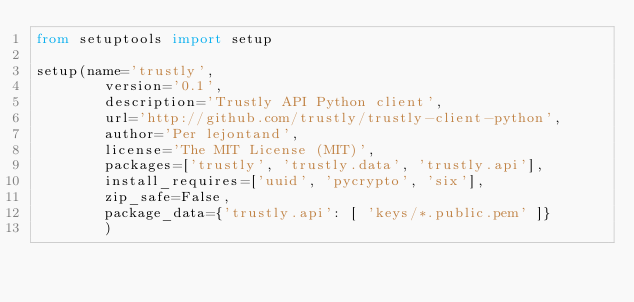<code> <loc_0><loc_0><loc_500><loc_500><_Python_>from setuptools import setup

setup(name='trustly',
        version='0.1',
        description='Trustly API Python client',
        url='http://github.com/trustly/trustly-client-python',
        author='Per lejontand',
        license='The MIT License (MIT)',
        packages=['trustly', 'trustly.data', 'trustly.api'],
        install_requires=['uuid', 'pycrypto', 'six'],
        zip_safe=False,
        package_data={'trustly.api': [ 'keys/*.public.pem' ]}
        )

</code> 